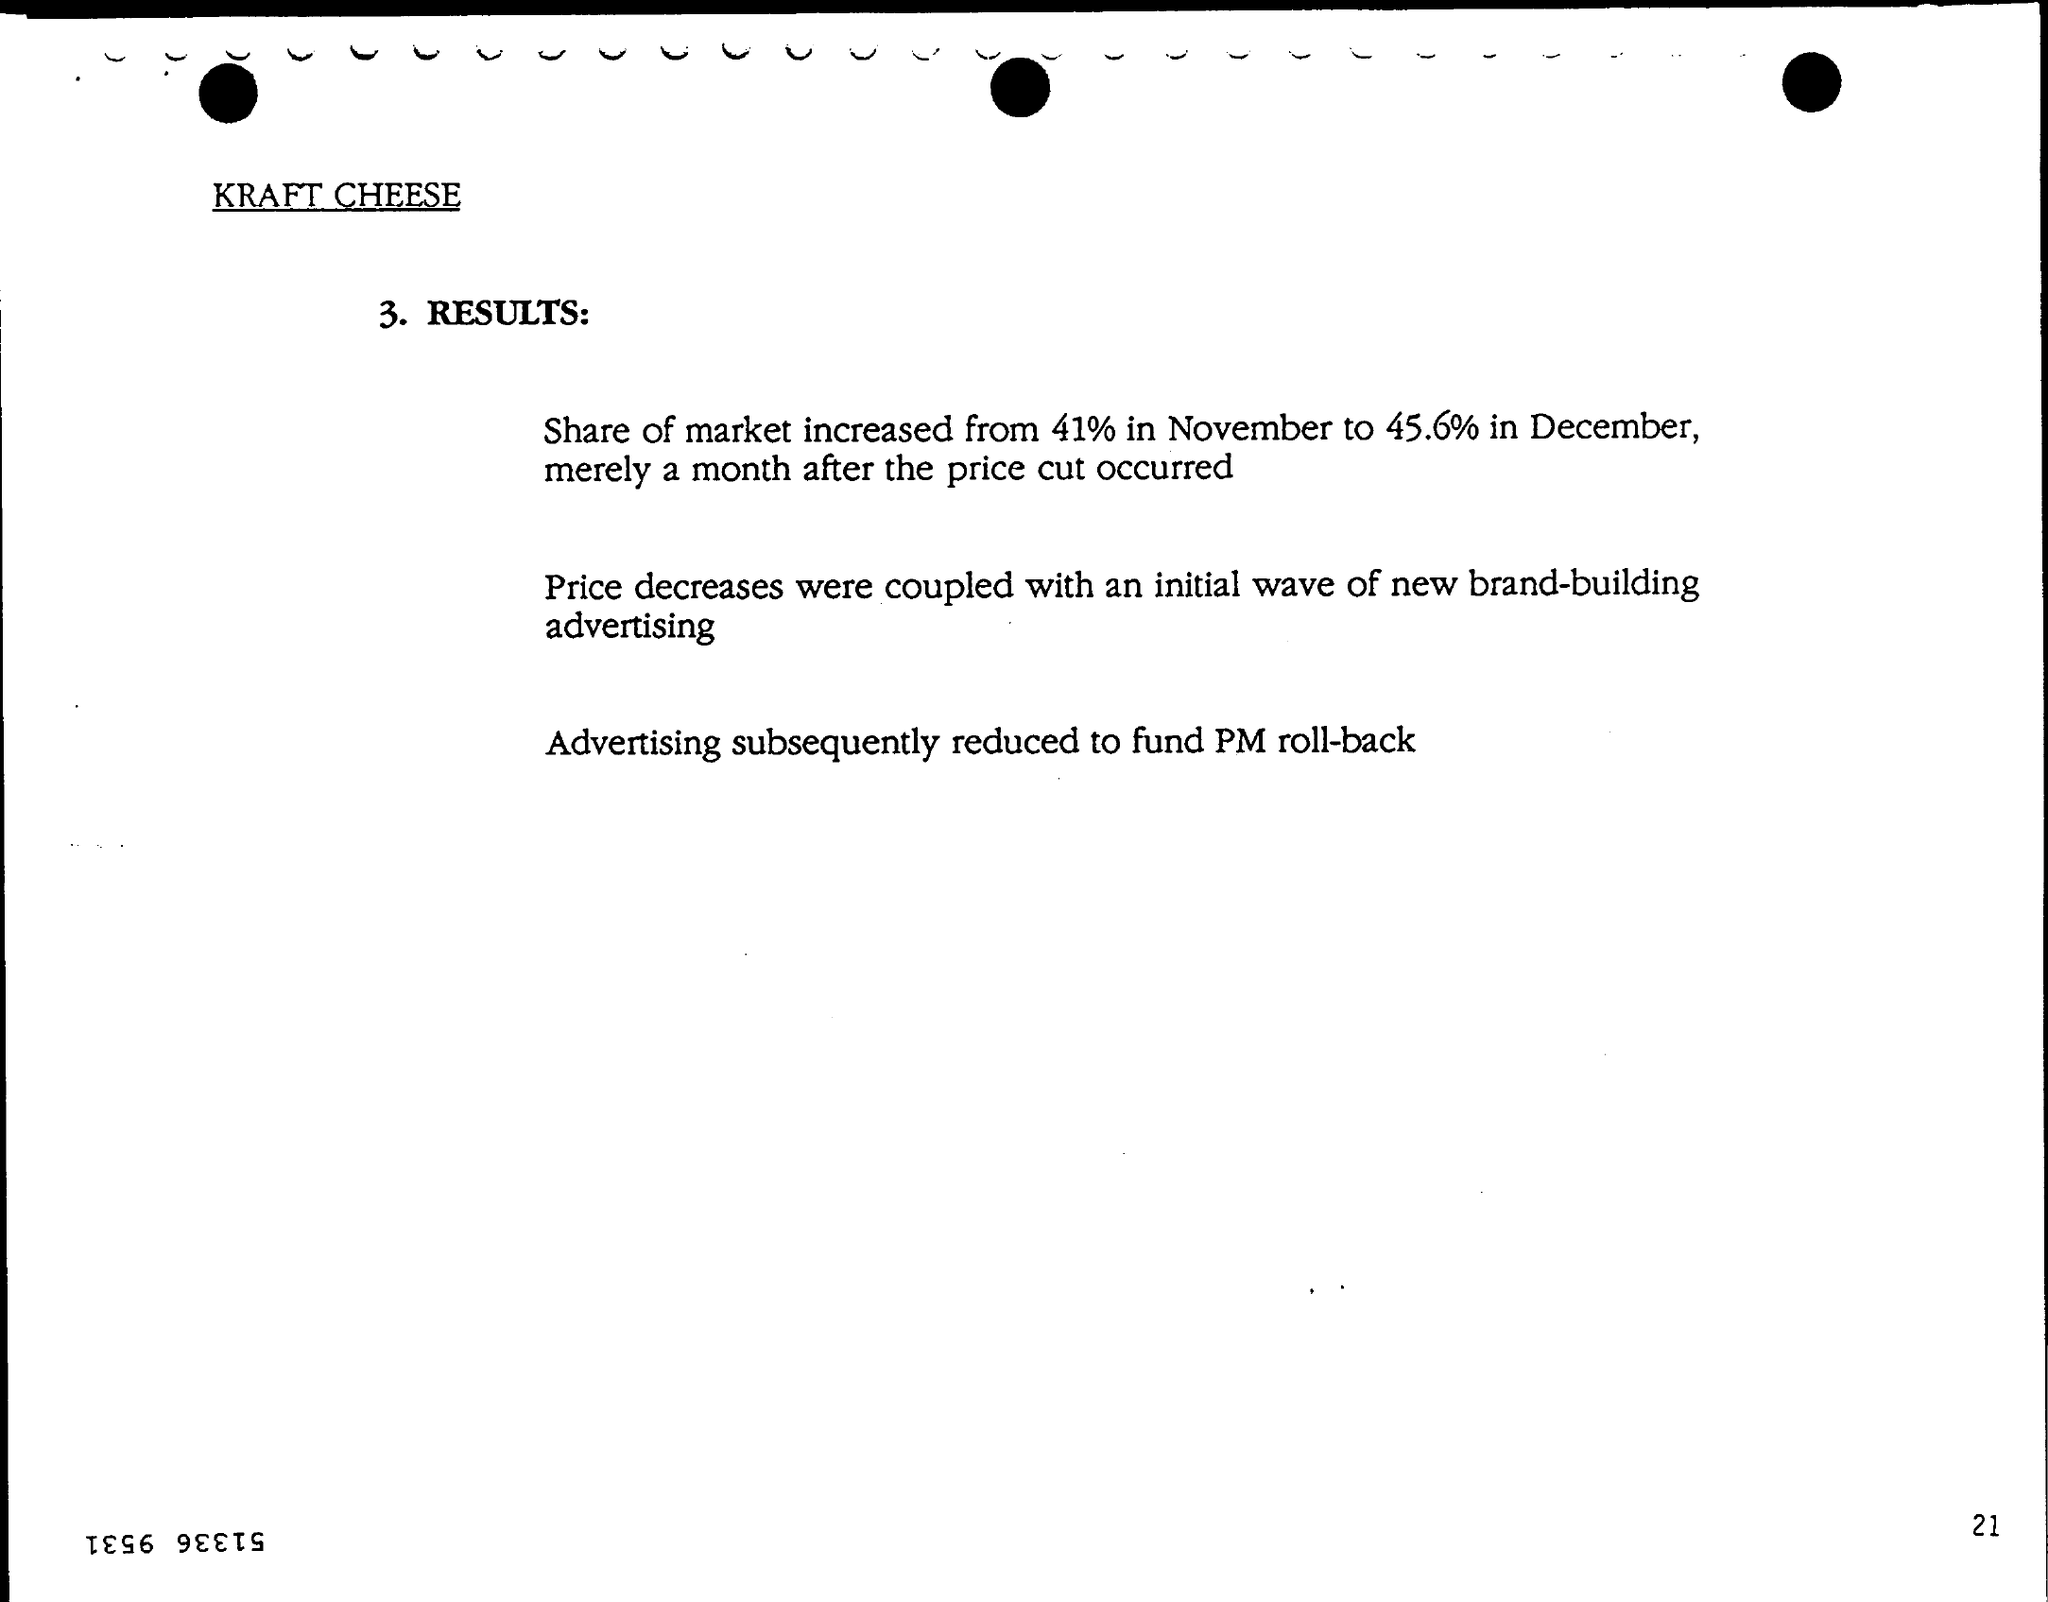What is the first title in the document?
Your answer should be very brief. Kraft Cheese. What is the Page Number?
Ensure brevity in your answer.  21. 